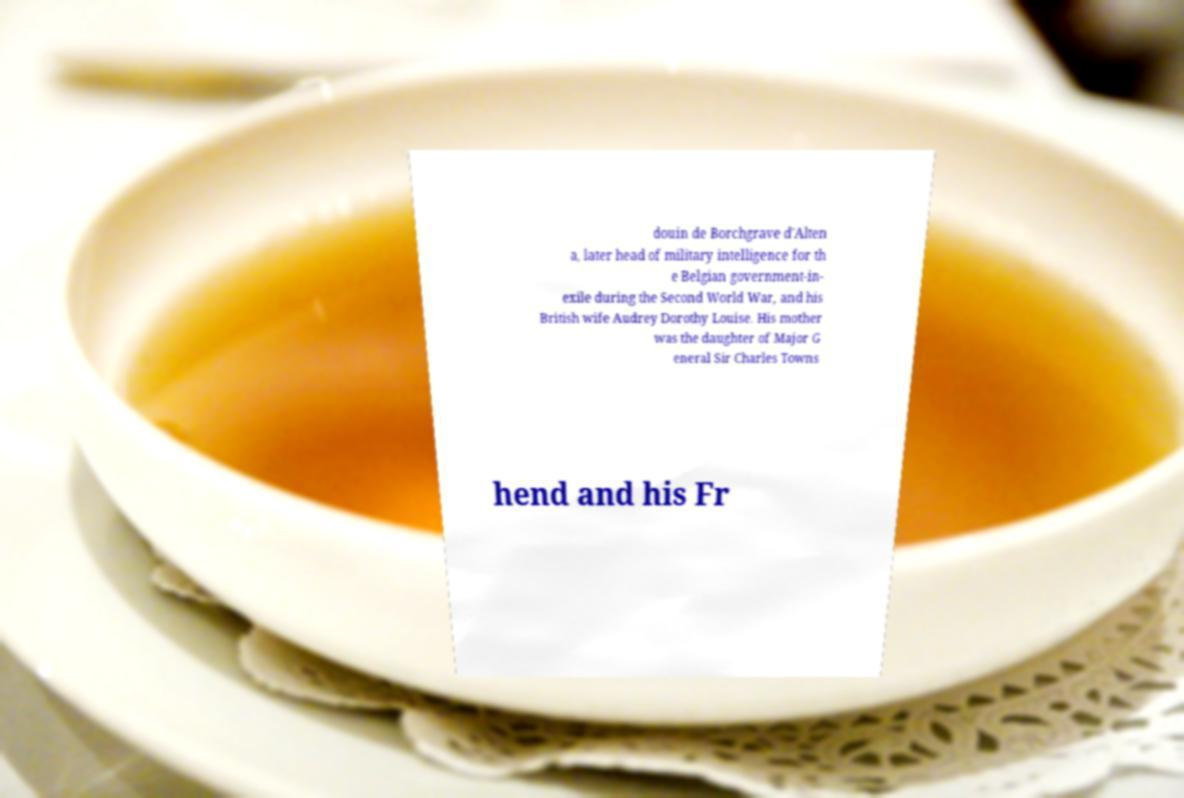Could you assist in decoding the text presented in this image and type it out clearly? douin de Borchgrave d'Alten a, later head of military intelligence for th e Belgian government-in- exile during the Second World War, and his British wife Audrey Dorothy Louise. His mother was the daughter of Major G eneral Sir Charles Towns hend and his Fr 